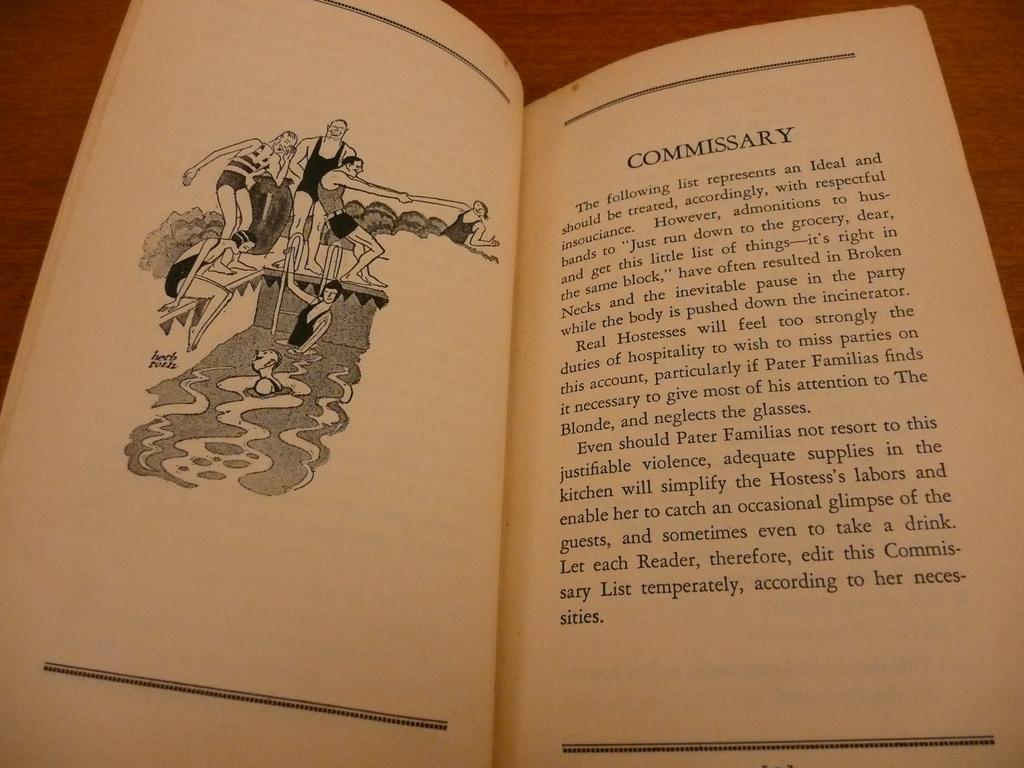What is this chapter's title?
Keep it short and to the point. Commissary. 